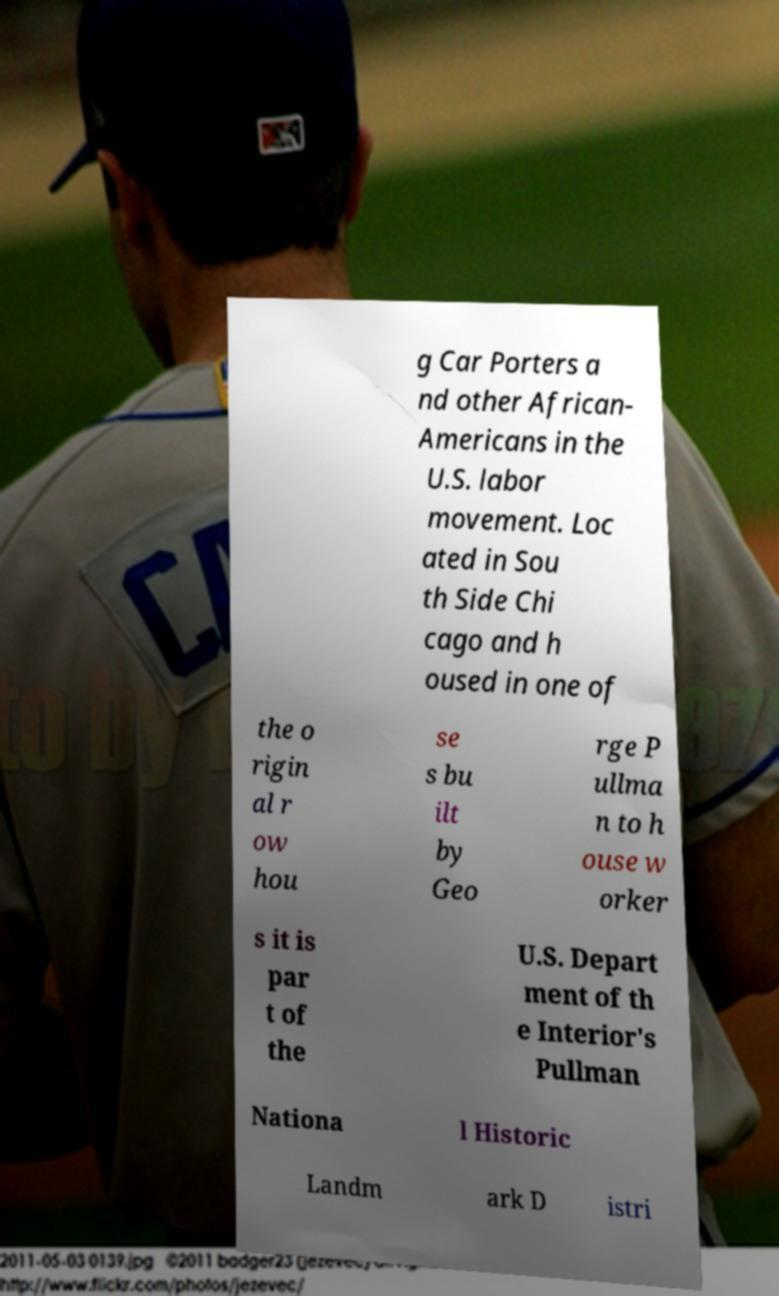Can you accurately transcribe the text from the provided image for me? g Car Porters a nd other African- Americans in the U.S. labor movement. Loc ated in Sou th Side Chi cago and h oused in one of the o rigin al r ow hou se s bu ilt by Geo rge P ullma n to h ouse w orker s it is par t of the U.S. Depart ment of th e Interior's Pullman Nationa l Historic Landm ark D istri 